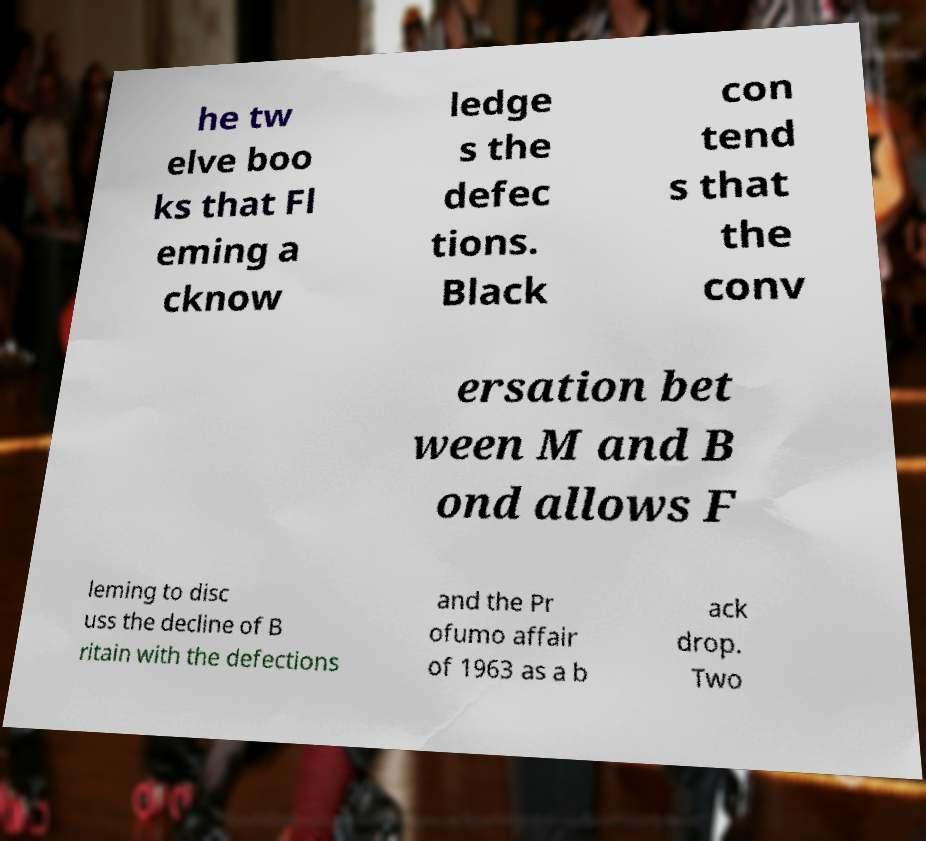Could you extract and type out the text from this image? he tw elve boo ks that Fl eming a cknow ledge s the defec tions. Black con tend s that the conv ersation bet ween M and B ond allows F leming to disc uss the decline of B ritain with the defections and the Pr ofumo affair of 1963 as a b ack drop. Two 